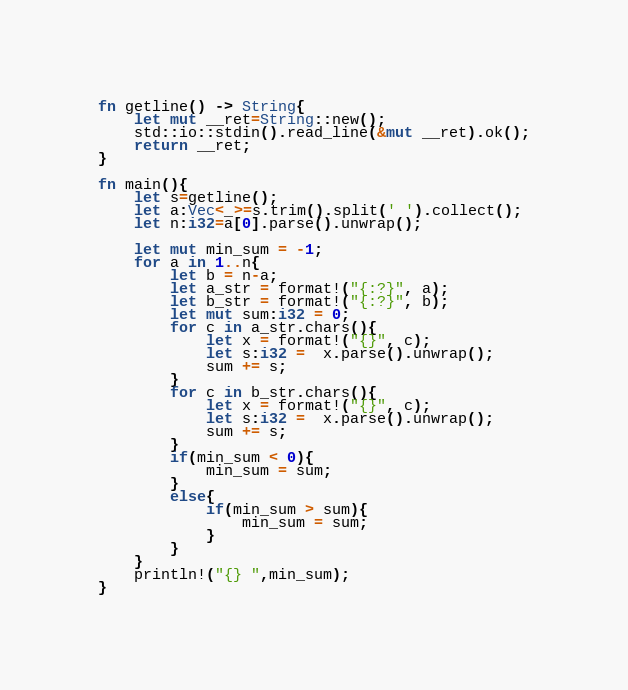Convert code to text. <code><loc_0><loc_0><loc_500><loc_500><_Rust_>fn getline() -> String{
    let mut __ret=String::new();
    std::io::stdin().read_line(&mut __ret).ok();
    return __ret;
}

fn main(){
    let s=getline();
    let a:Vec<_>=s.trim().split(' ').collect();
    let n:i32=a[0].parse().unwrap();

    let mut min_sum = -1;
    for a in 1..n{
        let b = n-a;
        let a_str = format!("{:?}", a);
        let b_str = format!("{:?}", b);
        let mut sum:i32 = 0;
        for c in a_str.chars(){
            let x = format!("{}", c);
            let s:i32 =  x.parse().unwrap();
            sum += s;
        }
        for c in b_str.chars(){
            let x = format!("{}", c);
            let s:i32 =  x.parse().unwrap();
            sum += s;
        }
        if(min_sum < 0){
            min_sum = sum;
        }
        else{
            if(min_sum > sum){
                min_sum = sum;
            }
        }
    }
    println!("{} ",min_sum);
}</code> 